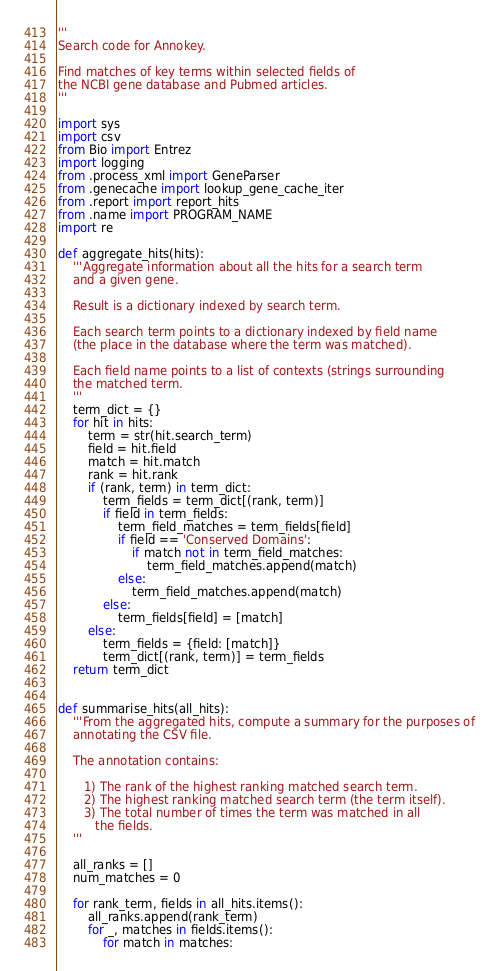Convert code to text. <code><loc_0><loc_0><loc_500><loc_500><_Python_>'''
Search code for Annokey.

Find matches of key terms within selected fields of
the NCBI gene database and Pubmed articles.
'''

import sys
import csv
from Bio import Entrez
import logging
from .process_xml import GeneParser
from .genecache import lookup_gene_cache_iter
from .report import report_hits
from .name import PROGRAM_NAME
import re

def aggregate_hits(hits):
    '''Aggregate information about all the hits for a search term
    and a given gene.

    Result is a dictionary indexed by search term.

    Each search term points to a dictionary indexed by field name
    (the place in the database where the term was matched).

    Each field name points to a list of contexts (strings surrounding
    the matched term.
    '''
    term_dict = {}
    for hit in hits:
        term = str(hit.search_term)
        field = hit.field
        match = hit.match
        rank = hit.rank
        if (rank, term) in term_dict:
            term_fields = term_dict[(rank, term)]
            if field in term_fields:
                term_field_matches = term_fields[field]
                if field == 'Conserved Domains':
                    if match not in term_field_matches:
                        term_field_matches.append(match)
                else:
                    term_field_matches.append(match)
            else:
                term_fields[field] = [match]
        else:
            term_fields = {field: [match]}
            term_dict[(rank, term)] = term_fields
    return term_dict


def summarise_hits(all_hits):
    '''From the aggregated hits, compute a summary for the purposes of
    annotating the CSV file.

    The annotation contains:

       1) The rank of the highest ranking matched search term.
       2) The highest ranking matched search term (the term itself).
       3) The total number of times the term was matched in all
          the fields.
    '''

    all_ranks = []
    num_matches = 0

    for rank_term, fields in all_hits.items():
        all_ranks.append(rank_term)
        for _, matches in fields.items():
            for match in matches:</code> 